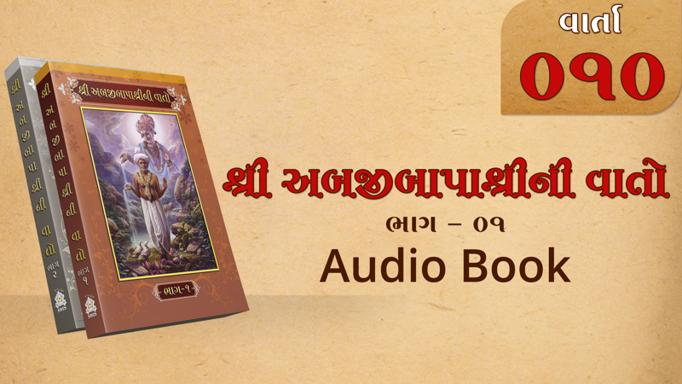Who is the central figure depicted on the cover of the book? The image on the book cover depicts a figure from Hindu mythology, which might suggest that the content of the book could involve traditional stories or teachings from Hindu texts. Can you tell me more about the story or content? While the specific details of the content are not visible, the imagery and the style typically indicate themes surrounding Hindu mythology or spiritual teachings, perhaps focusing on historic narratives, moral lessons, or religious guidance. 